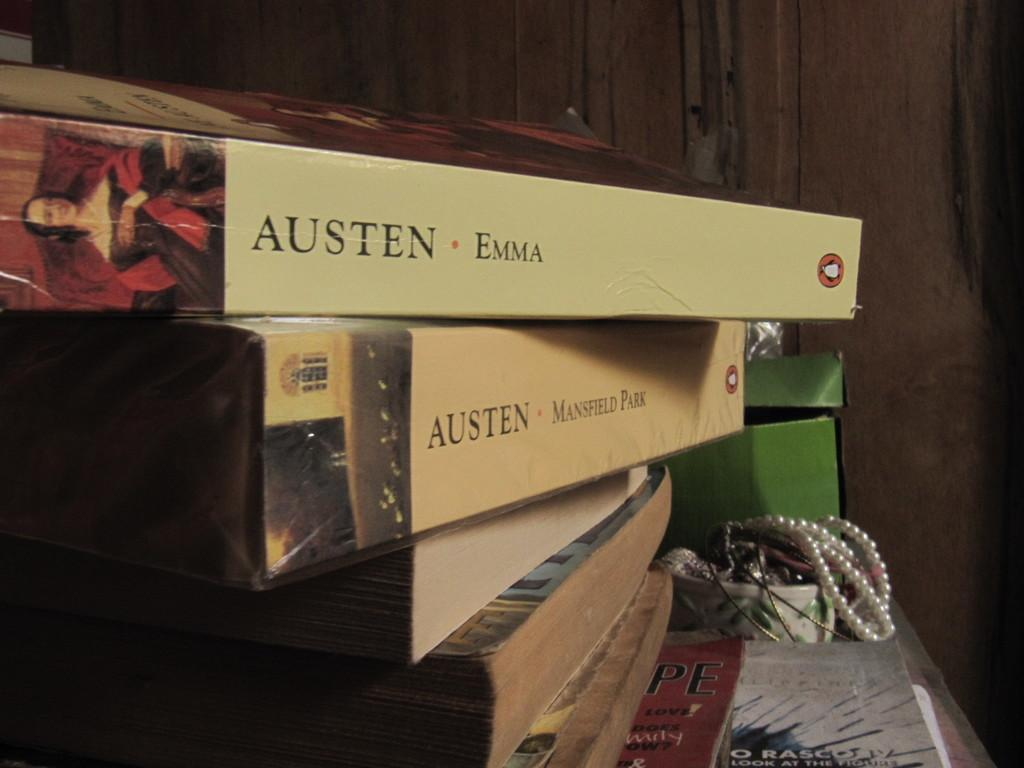Provide a one-sentence caption for the provided image. jane austen books stacked one is called emma. 